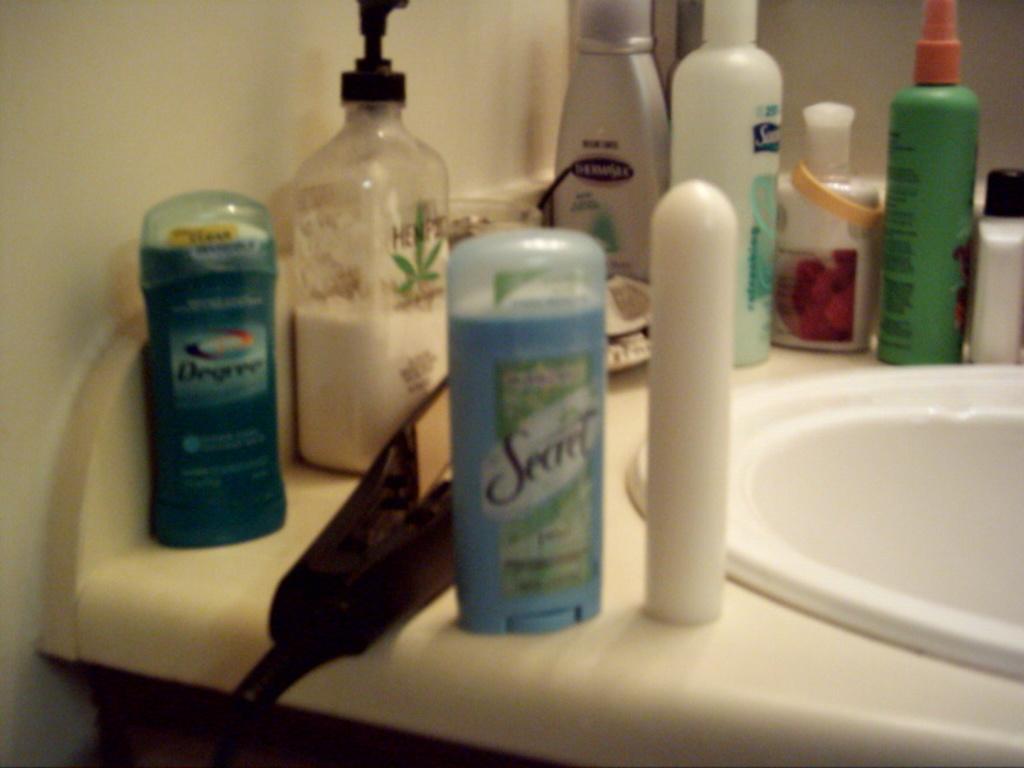What is the brand of deodorant in the light blue container?
Offer a terse response. Secret. What is the brand of deodorant next to the wall?
Offer a terse response. Degree. 